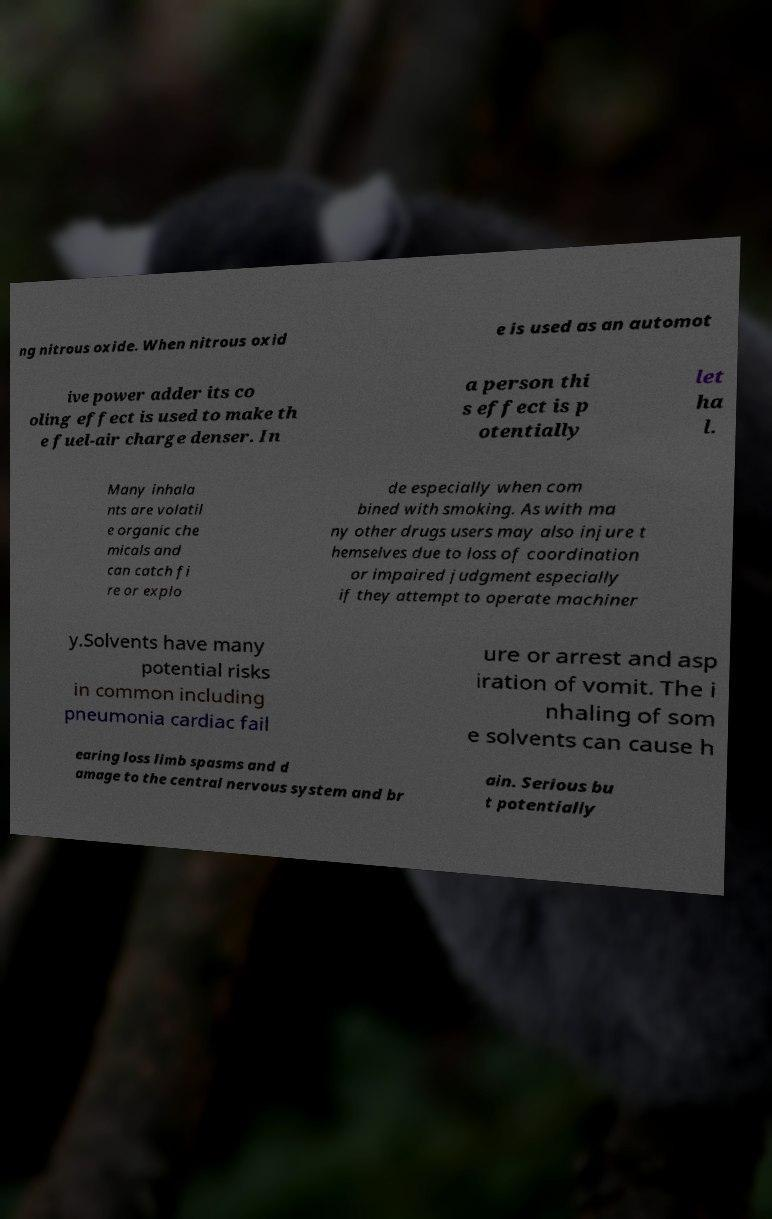I need the written content from this picture converted into text. Can you do that? ng nitrous oxide. When nitrous oxid e is used as an automot ive power adder its co oling effect is used to make th e fuel-air charge denser. In a person thi s effect is p otentially let ha l. Many inhala nts are volatil e organic che micals and can catch fi re or explo de especially when com bined with smoking. As with ma ny other drugs users may also injure t hemselves due to loss of coordination or impaired judgment especially if they attempt to operate machiner y.Solvents have many potential risks in common including pneumonia cardiac fail ure or arrest and asp iration of vomit. The i nhaling of som e solvents can cause h earing loss limb spasms and d amage to the central nervous system and br ain. Serious bu t potentially 